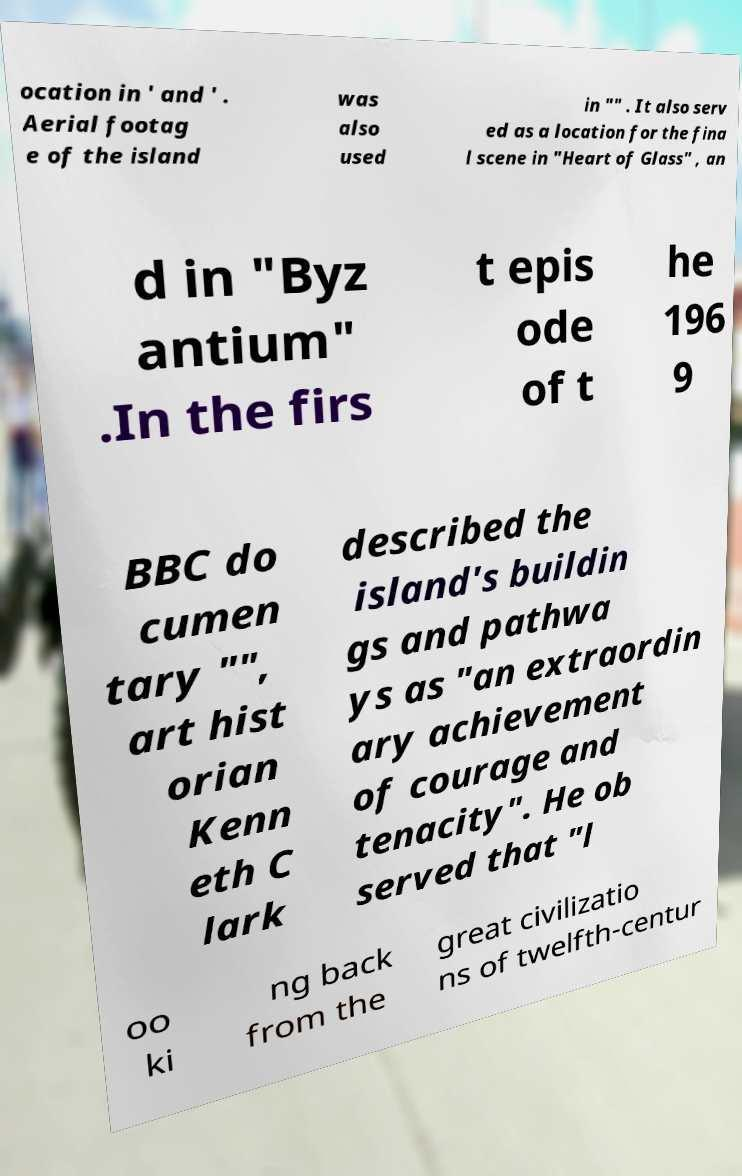Could you assist in decoding the text presented in this image and type it out clearly? ocation in ' and ' . Aerial footag e of the island was also used in "" . It also serv ed as a location for the fina l scene in "Heart of Glass" , an d in "Byz antium" .In the firs t epis ode of t he 196 9 BBC do cumen tary "", art hist orian Kenn eth C lark described the island's buildin gs and pathwa ys as "an extraordin ary achievement of courage and tenacity". He ob served that "l oo ki ng back from the great civilizatio ns of twelfth-centur 